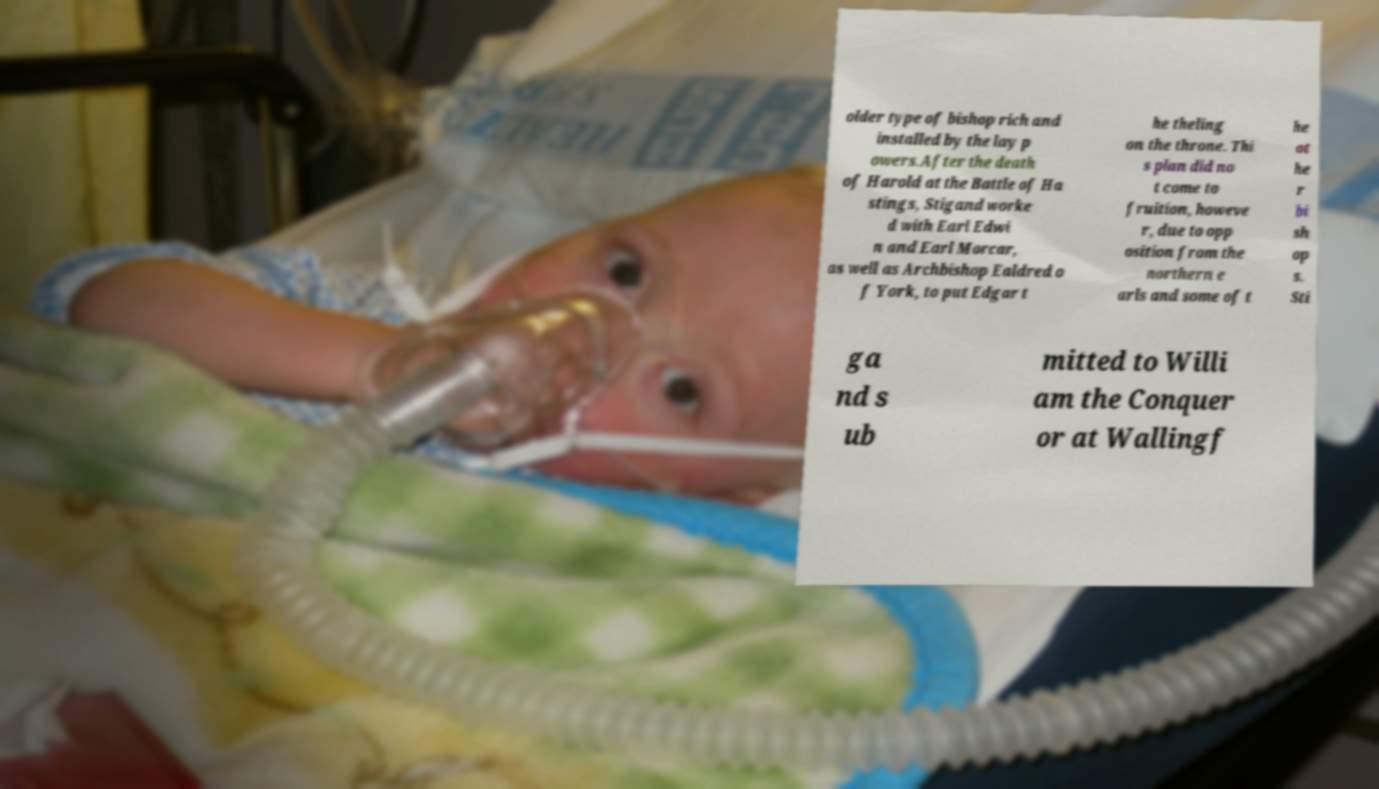Please identify and transcribe the text found in this image. older type of bishop rich and installed by the lay p owers.After the death of Harold at the Battle of Ha stings, Stigand worke d with Earl Edwi n and Earl Morcar, as well as Archbishop Ealdred o f York, to put Edgar t he theling on the throne. Thi s plan did no t come to fruition, howeve r, due to opp osition from the northern e arls and some of t he ot he r bi sh op s. Sti ga nd s ub mitted to Willi am the Conquer or at Wallingf 